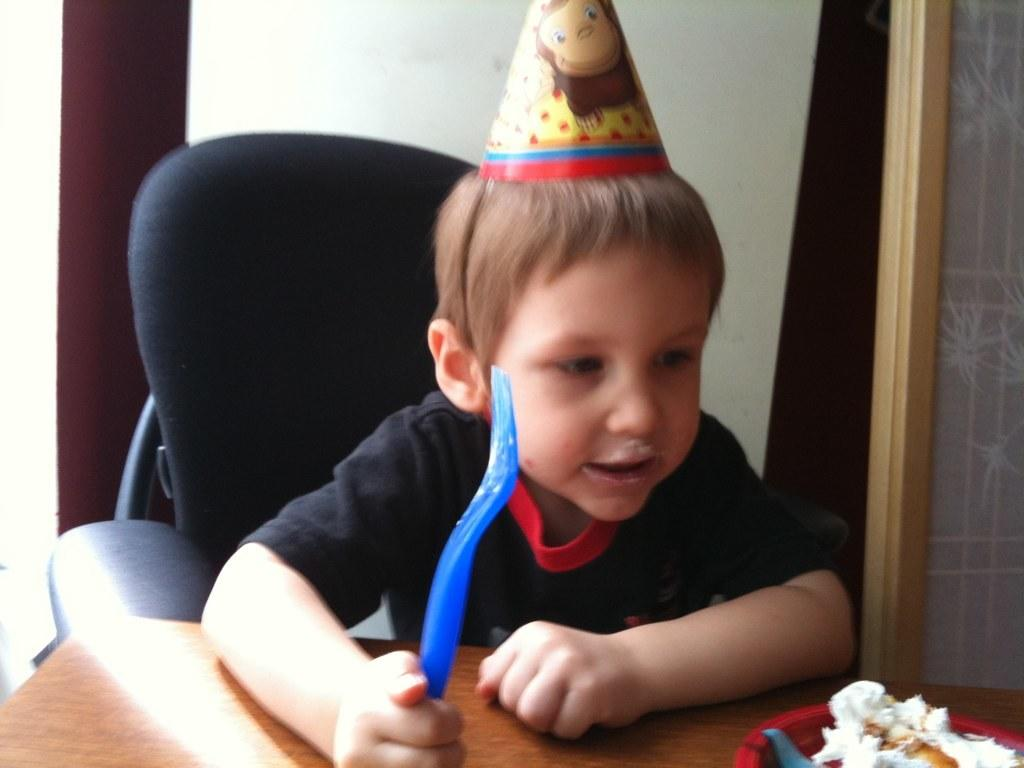What is the kid doing in the image? The kid is sitting on a chair in the image. Where is the chair located? The chair is at a table. What is on the table besides the chair? There is a bowl and food items on the table. What can be seen in the background of the image? There is a wall and a window in the background of the image. What type of lace is draped over the window in the image? There is no lace present in the image; the window is visible without any drapery. 